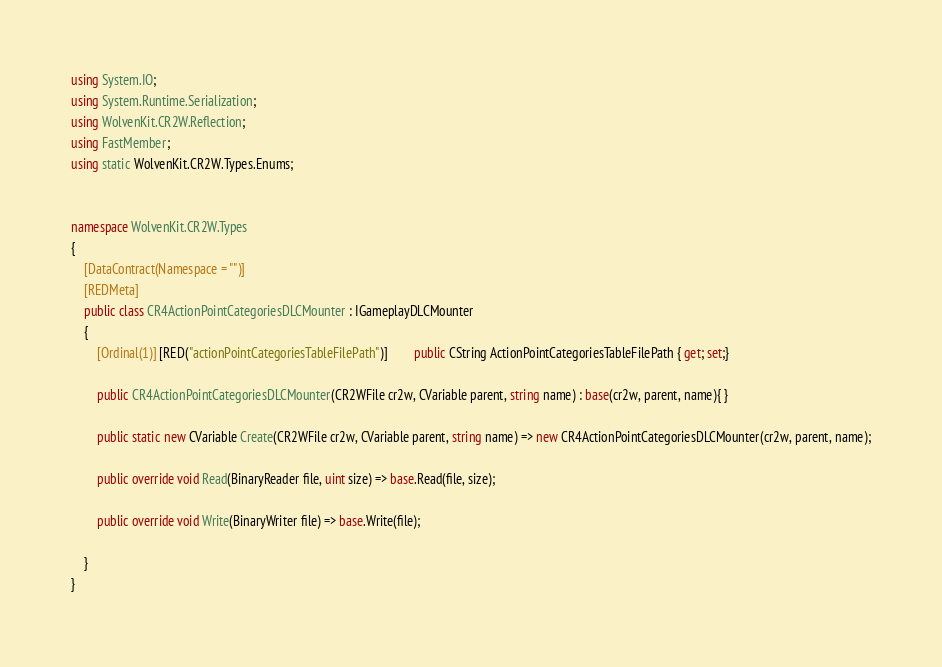<code> <loc_0><loc_0><loc_500><loc_500><_C#_>using System.IO;
using System.Runtime.Serialization;
using WolvenKit.CR2W.Reflection;
using FastMember;
using static WolvenKit.CR2W.Types.Enums;


namespace WolvenKit.CR2W.Types
{
	[DataContract(Namespace = "")]
	[REDMeta]
	public class CR4ActionPointCategoriesDLCMounter : IGameplayDLCMounter
	{
		[Ordinal(1)] [RED("actionPointCategoriesTableFilePath")] 		public CString ActionPointCategoriesTableFilePath { get; set;}

		public CR4ActionPointCategoriesDLCMounter(CR2WFile cr2w, CVariable parent, string name) : base(cr2w, parent, name){ }

		public static new CVariable Create(CR2WFile cr2w, CVariable parent, string name) => new CR4ActionPointCategoriesDLCMounter(cr2w, parent, name);

		public override void Read(BinaryReader file, uint size) => base.Read(file, size);

		public override void Write(BinaryWriter file) => base.Write(file);

	}
}</code> 